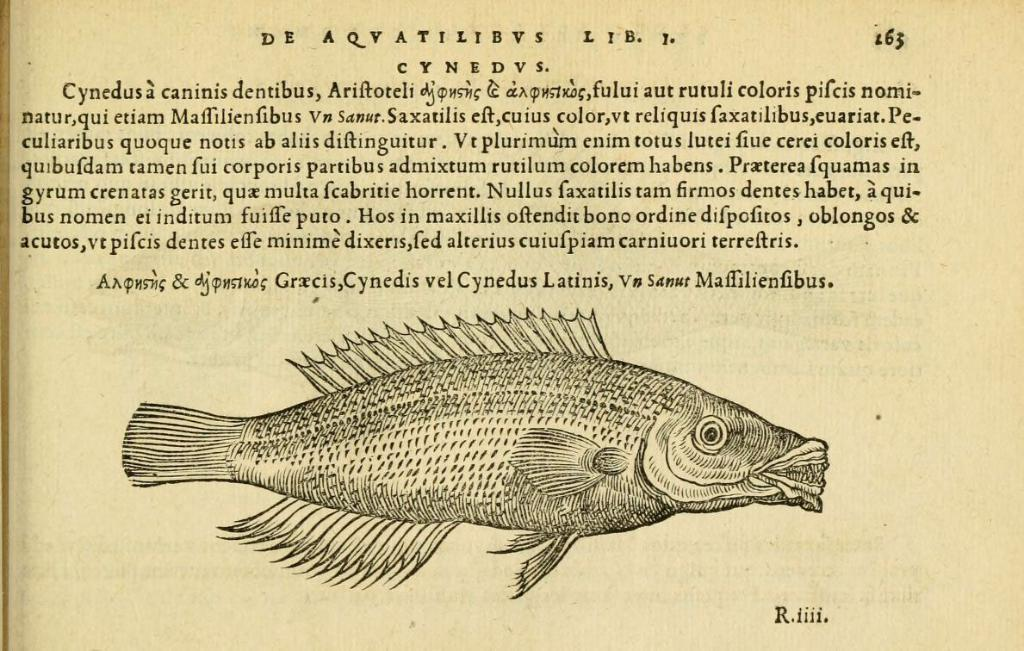What is the main subject of the image? The main subject of the image is a paper. What is depicted on the paper? There is a picture of a fish on the paper. Are there any words or letters on the paper? Yes, there is text on the paper. What color is the skirt worn by the fish in the image? There is no skirt or fish wearing a skirt in the image; it features a picture of a fish on a paper with text. 